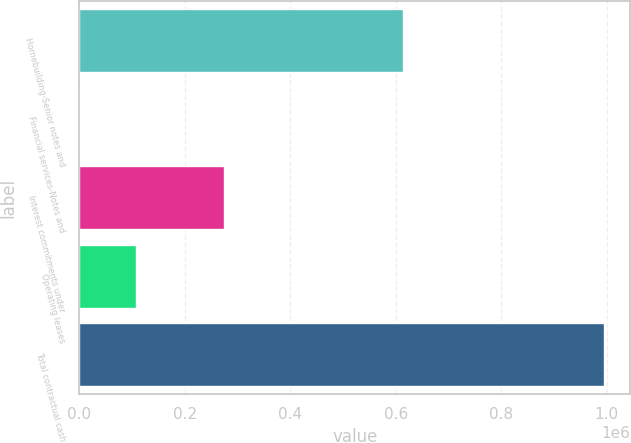<chart> <loc_0><loc_0><loc_500><loc_500><bar_chart><fcel>Homebuilding-Senior notes and<fcel>Financial services-Notes and<fcel>Interest commitments under<fcel>Operating leases<fcel>Total contractual cash<nl><fcel>613940<fcel>171<fcel>273463<fcel>107213<fcel>994787<nl></chart> 